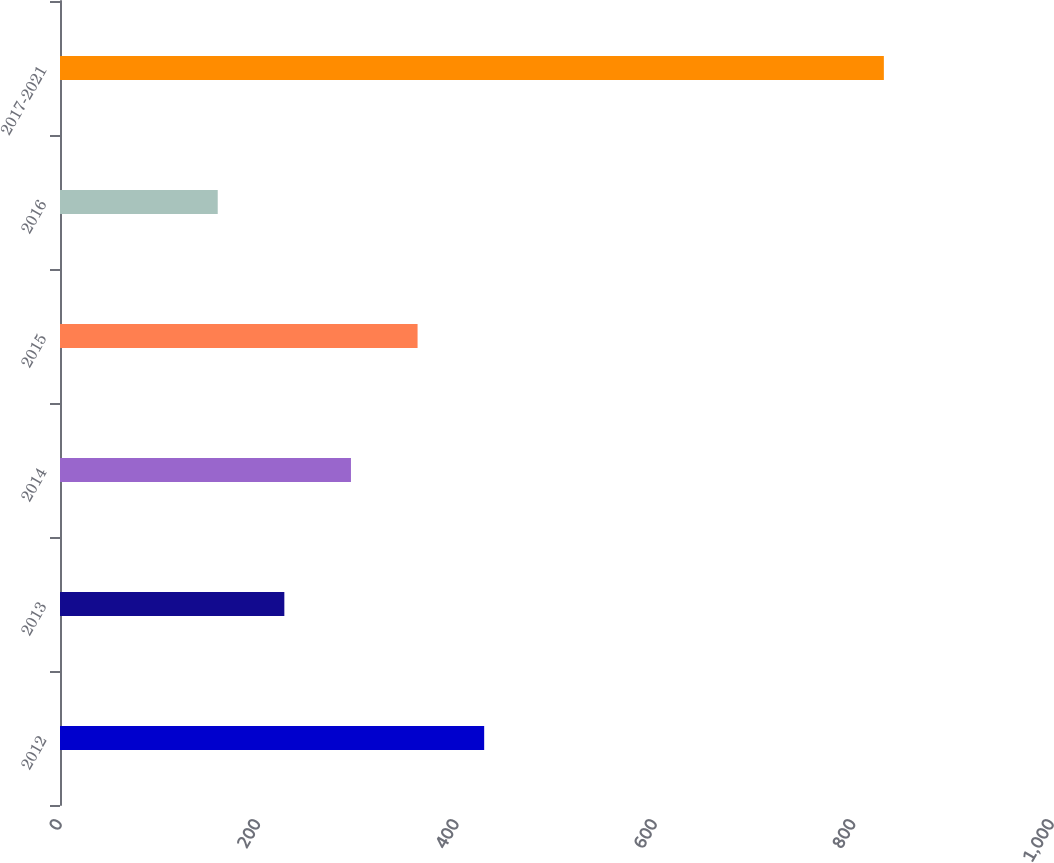<chart> <loc_0><loc_0><loc_500><loc_500><bar_chart><fcel>2012<fcel>2013<fcel>2014<fcel>2015<fcel>2016<fcel>2017-2021<nl><fcel>427.6<fcel>226.15<fcel>293.3<fcel>360.45<fcel>159<fcel>830.5<nl></chart> 